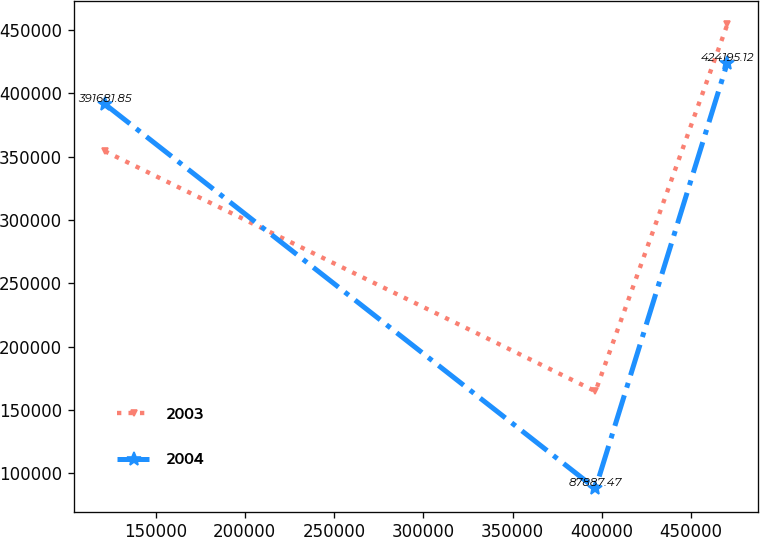<chart> <loc_0><loc_0><loc_500><loc_500><line_chart><ecel><fcel>2003<fcel>2004<nl><fcel>121512<fcel>354435<fcel>391682<nl><fcel>396487<fcel>164662<fcel>87887.5<nl><fcel>470369<fcel>454507<fcel>424195<nl></chart> 